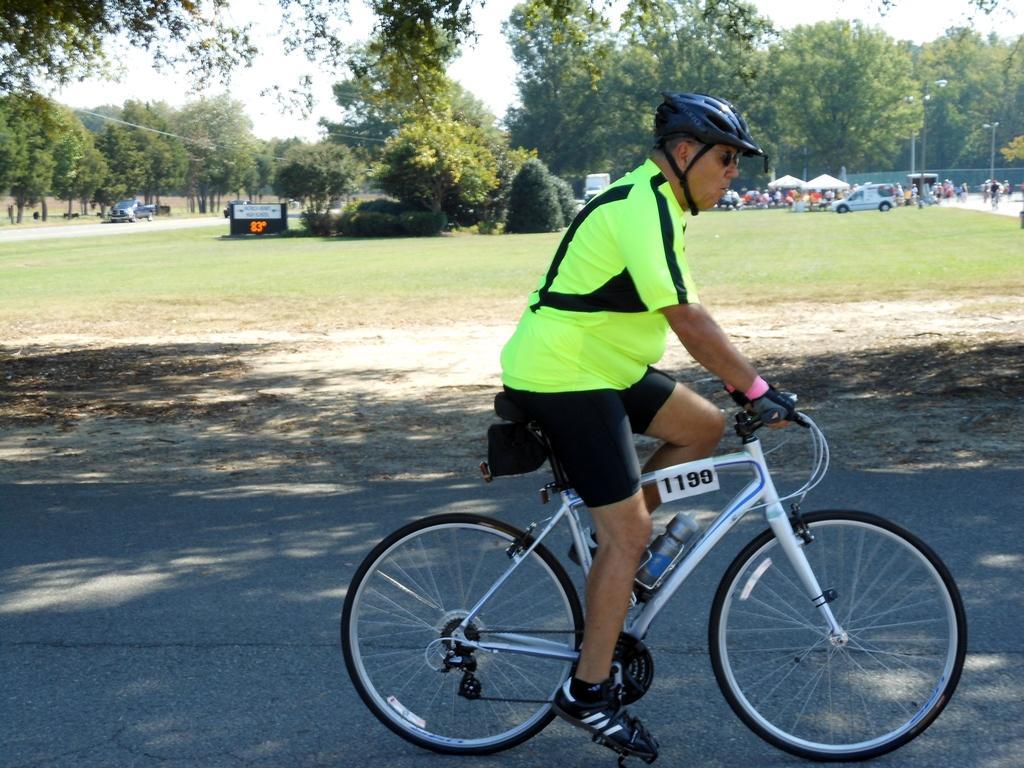Could you give a brief overview of what you see in this image? In this image I can see the road. I can see a person sitting on the bicycle. I can see the grass and a board with some text written on it. In the background, I can see the vehicles and the trees. 